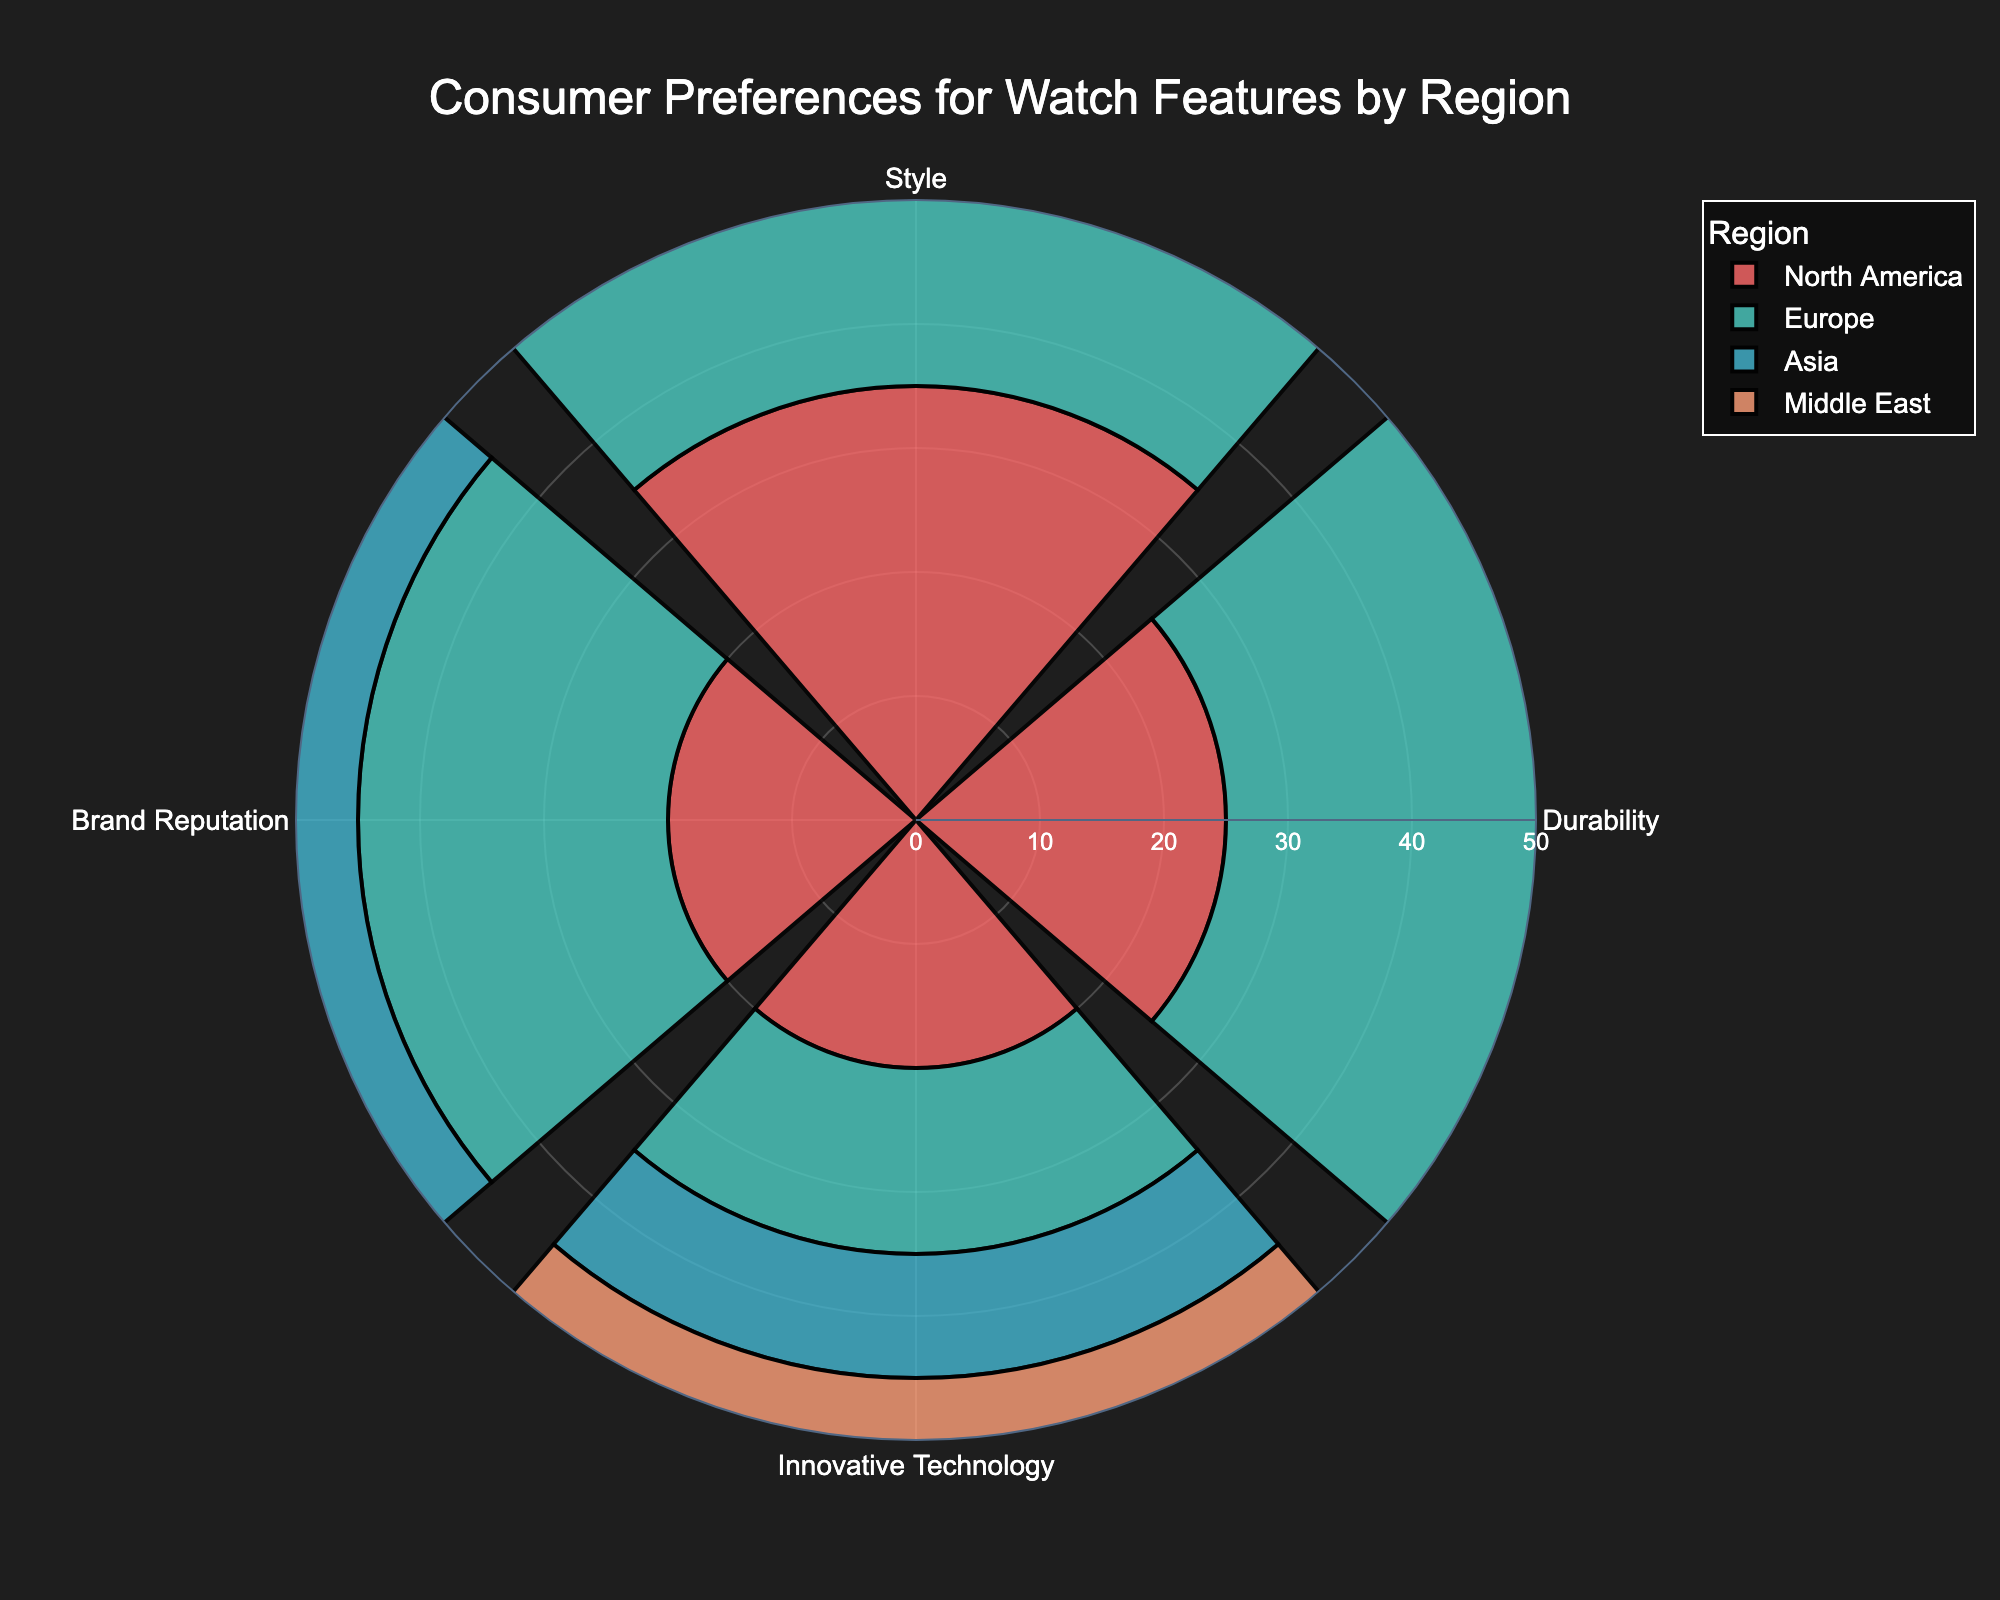What is the most preferred watch feature in North America? The chart shows four features, where "Style" is visibly the largest segment in North America.
Answer: Style Which region values "Brand Reputation" the most? Looking at the segments labeled "Brand Reputation," the largest segment appears in the Middle East.
Answer: Middle East Which feature is least preferred in Asia? By inspecting the segments corresponding to Asia, "Innovative Technology" has the smallest segment.
Answer: Innovative Technology What is the total percentage of consumers in Europe who prefer either "Durability" or "Style"? The Europe segments for "Durability" and "Style" are each 30%. Adding these together: 30% + 30% = 60%.
Answer: 60% Compare the preference for "Innovative Technology" between North America and Asia. Which region has a higher percentage? North America's segment for "Innovative Technology" is 20%, while Asia's is 10%. North America has a higher percentage.
Answer: North America How does the preference for "Durability" in North America compare to Europe? North America has a "Durability" preference of 25%, while Europe has 30%. Europe has a higher preference for "Durability."
Answer: Europe What is the most significant preference difference for any feature between North America and the Middle East? The most significant difference is in "Durability," with North America at 25% and the Middle East at 15%, resulting in a difference of 10%.
Answer: Durability If you average the preference for "Style" across all regions, what do you get? Adding the "Style" preferences: 35% (North America) + 30% (Europe) + 40% (Asia) + 25% (Middle East) = 130%. Then, dividing by 4 regions: 130% / 4 = 32.5%.
Answer: 32.5% Which feature has the highest combined percentage across all regions? Adding each feature's values: Durability: 25 + 30 + 20 + 15 = 90%; Style: 35 + 30 + 40 + 25 = 130%; Brand Reputation: 20 + 25 + 30 + 35 = 110%; Innovative Technology: 20 + 15 + 10 + 25 = 70%. "Style" has the highest total at 130%.
Answer: Style Which region has the least varied (most balanced) preferences across all features? Examining the percentages for each region, Europe has 30%, 30%, 25%, and 15%, showing less variation between features compared to other regions.
Answer: Europe 